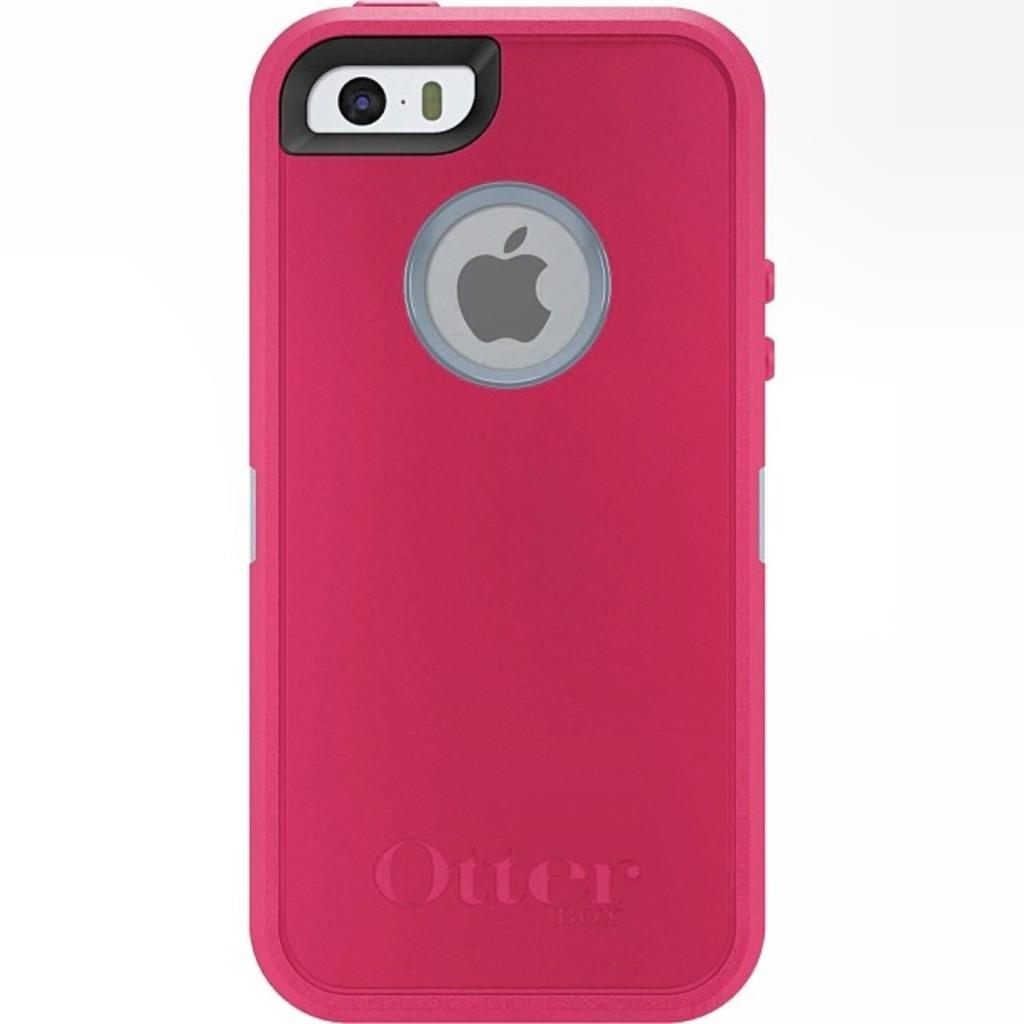In one or two sentences, can you explain what this image depicts? In this image there is a back side of the mobile phone which is pink in colour. 